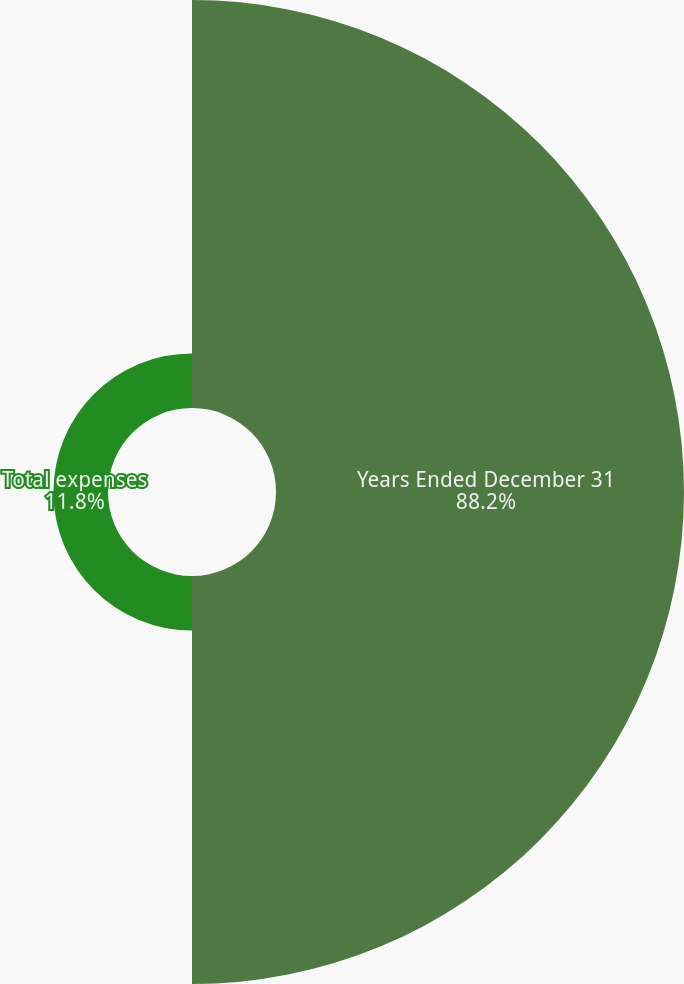<chart> <loc_0><loc_0><loc_500><loc_500><pie_chart><fcel>Years Ended December 31<fcel>Total expenses<nl><fcel>88.2%<fcel>11.8%<nl></chart> 